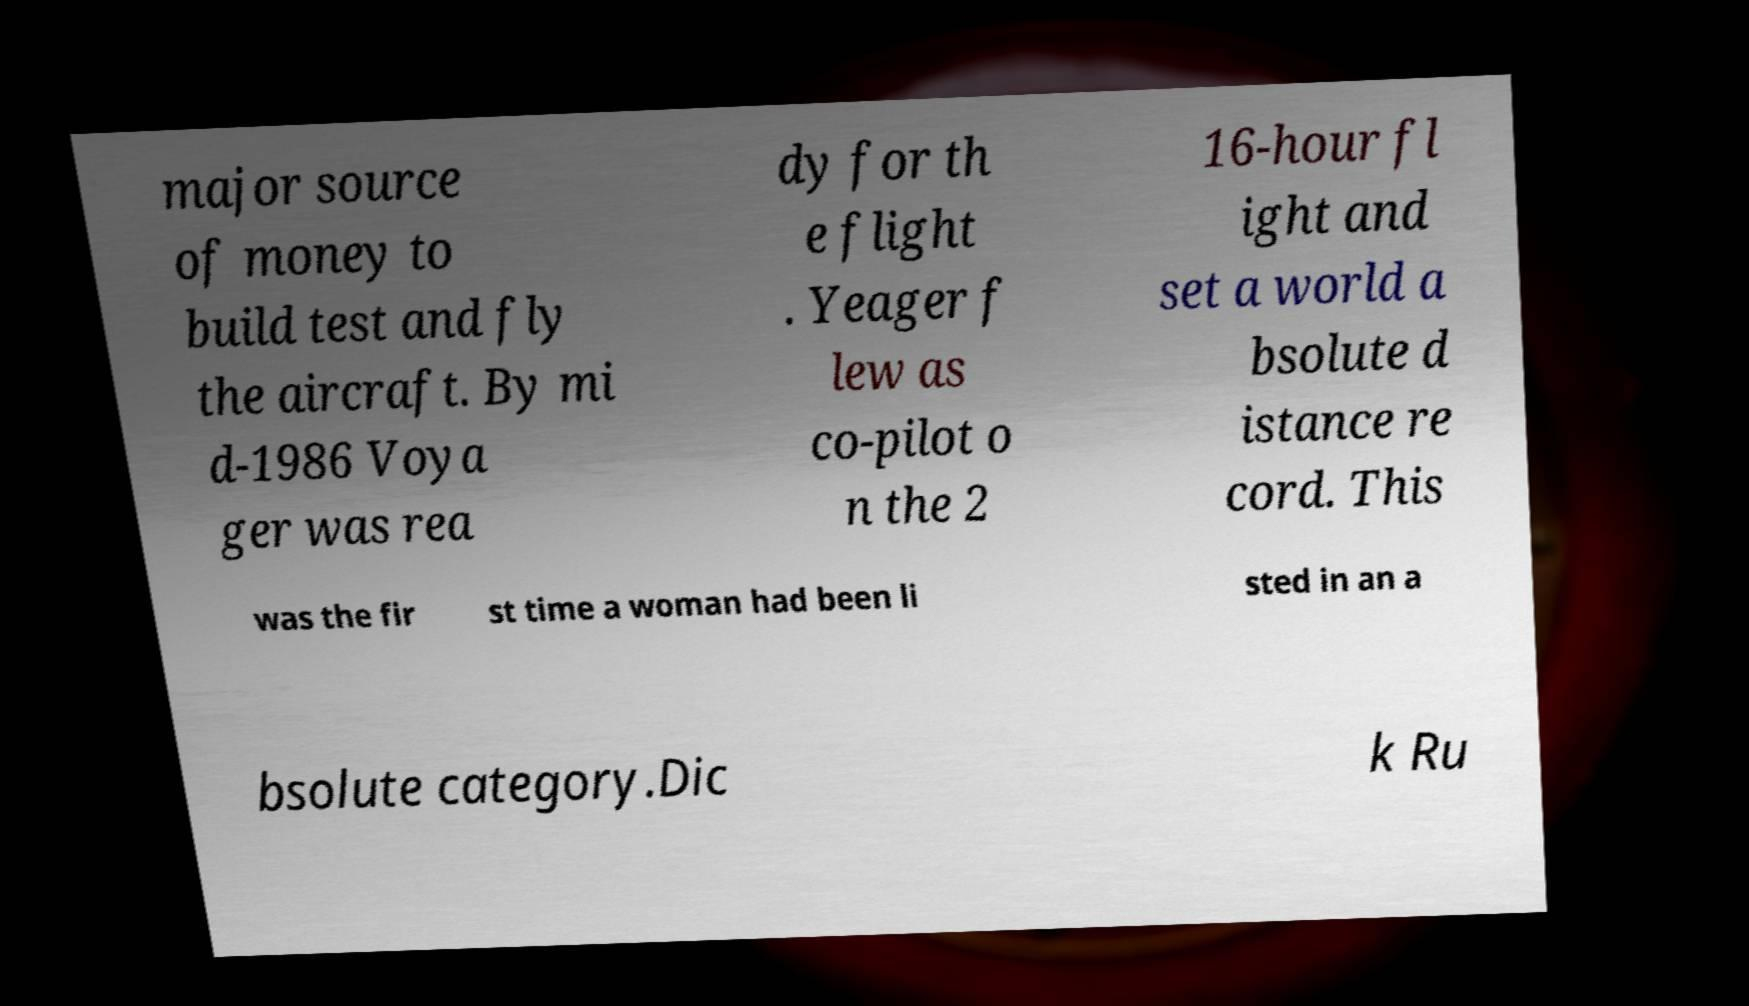For documentation purposes, I need the text within this image transcribed. Could you provide that? major source of money to build test and fly the aircraft. By mi d-1986 Voya ger was rea dy for th e flight . Yeager f lew as co-pilot o n the 2 16-hour fl ight and set a world a bsolute d istance re cord. This was the fir st time a woman had been li sted in an a bsolute category.Dic k Ru 